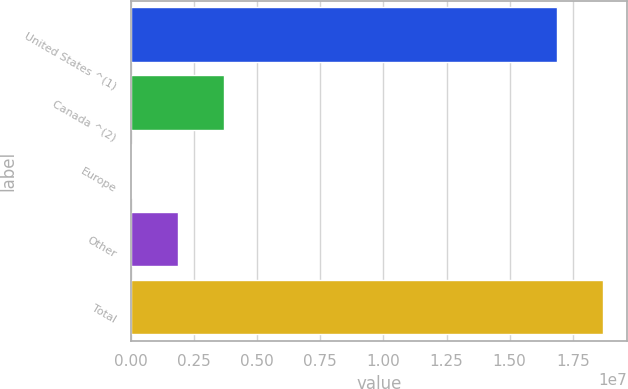<chart> <loc_0><loc_0><loc_500><loc_500><bar_chart><fcel>United States ^(1)<fcel>Canada ^(2)<fcel>Europe<fcel>Other<fcel>Total<nl><fcel>1.68945e+07<fcel>3.66535e+06<fcel>25011<fcel>1.84518e+06<fcel>1.87146e+07<nl></chart> 